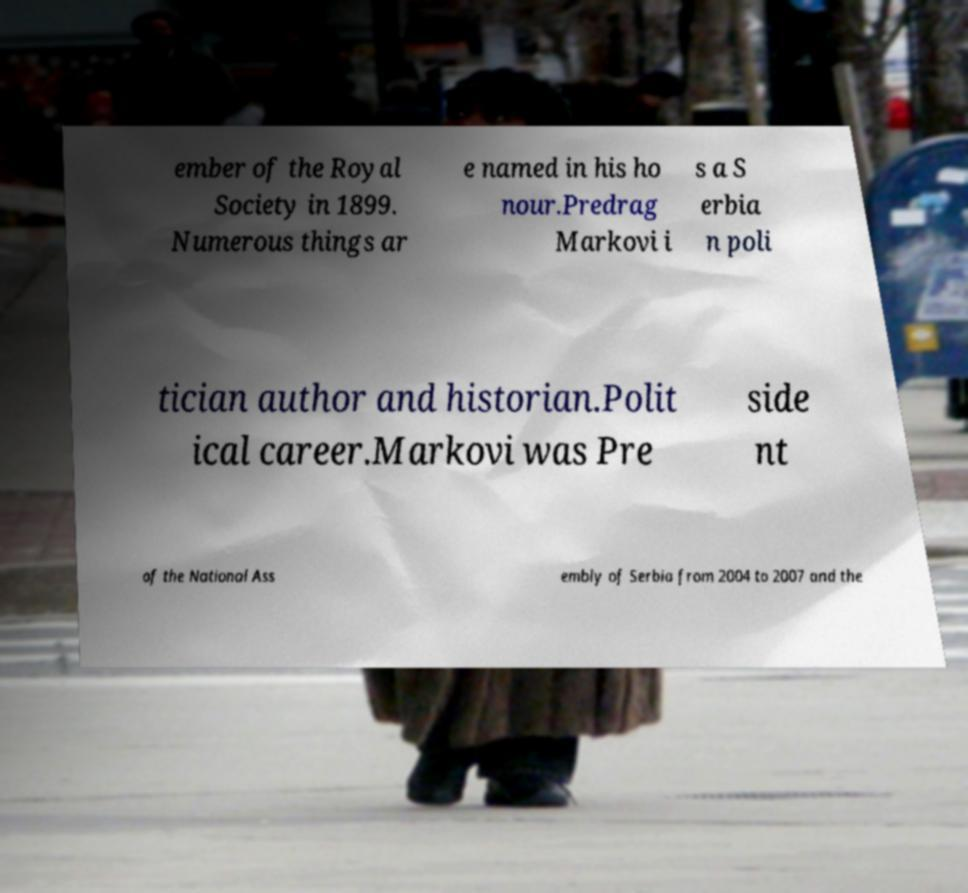Can you accurately transcribe the text from the provided image for me? ember of the Royal Society in 1899. Numerous things ar e named in his ho nour.Predrag Markovi i s a S erbia n poli tician author and historian.Polit ical career.Markovi was Pre side nt of the National Ass embly of Serbia from 2004 to 2007 and the 